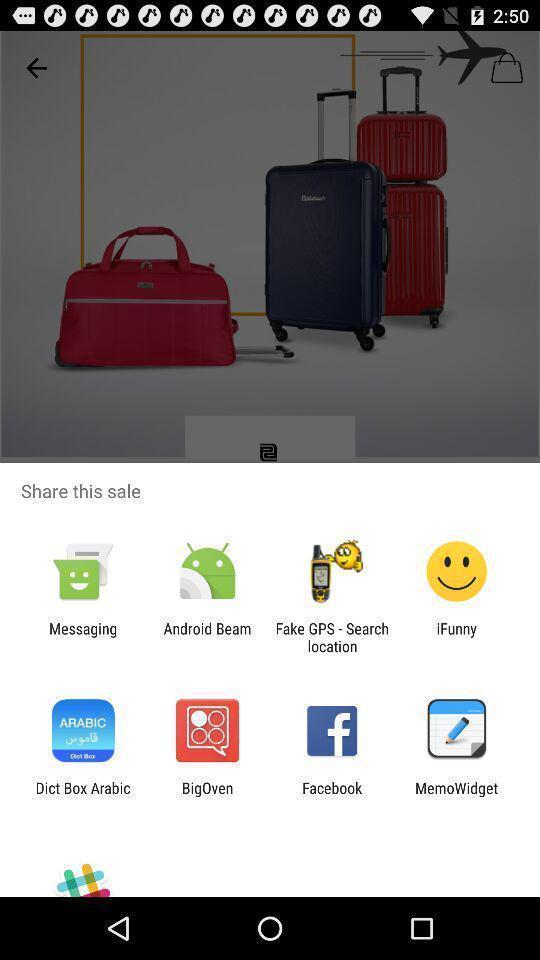Provide a textual representation of this image. Popup showing various apps. 